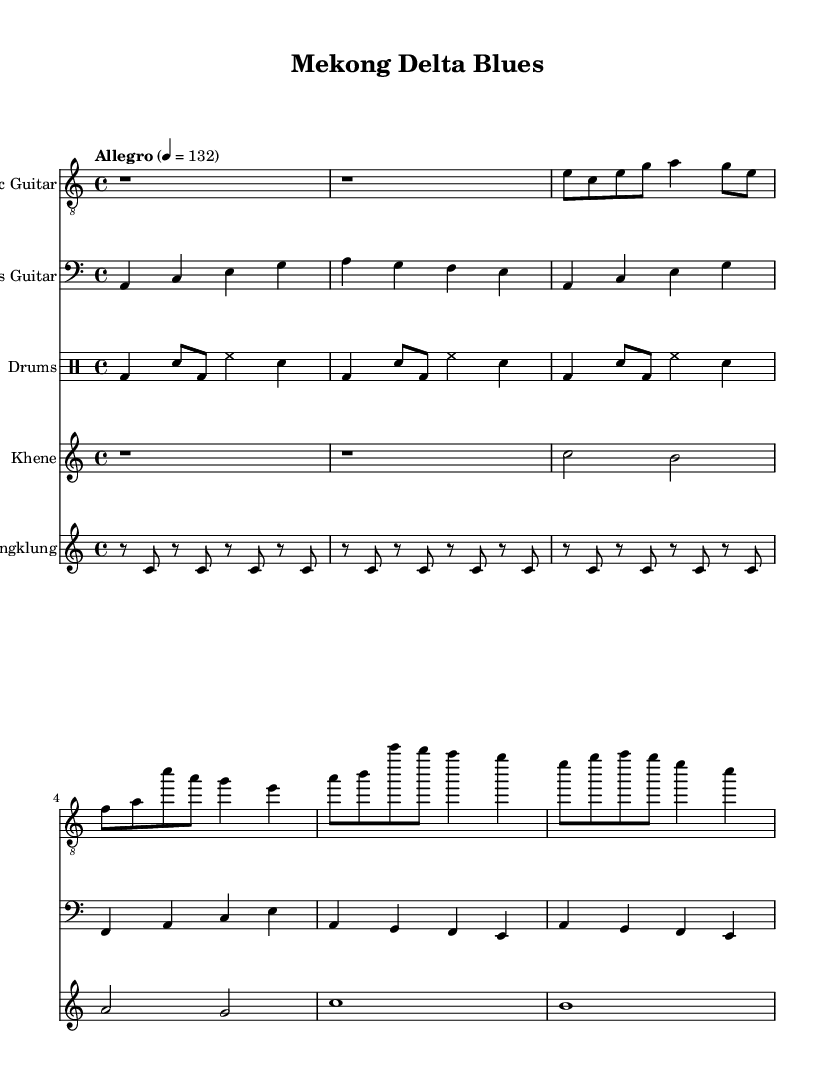What is the key signature of this music? The key signature is A minor, which has no sharps or flats, as indicated at the start of the music notation.
Answer: A minor What is the time signature of this music? The time signature is 4/4, which is typically denoted at the beginning of the piece. It shows there are four beats in each measure.
Answer: 4/4 What is the tempo marking for this piece? The tempo marking indicates "Allegro" at a speed of 132 beats per minute, which is specified in the header section of the music.
Answer: Allegro, 132 How many measures are in the intro section? The intro section consists of 2 measures, which can be seen with two "r1" notations indicating rests lasting one whole measure each.
Answer: 2 What instruments are featured in this piece? The instruments depicted include Electric Guitar, Bass Guitar, Drums, Khene, and Angklung, as labeled at the top of each staff.
Answer: Electric Guitar, Bass Guitar, Drums, Khene, Angklung How does the chorus differ from the verse in terms of melody? The chorus section generally has a more repetitive structure with clear melodic peaks, while the verse has a more varied line, providing contrast. This can be deduced by comparing the melodic content of the two sections in the sheet music.
Answer: More repetitive in the chorus 